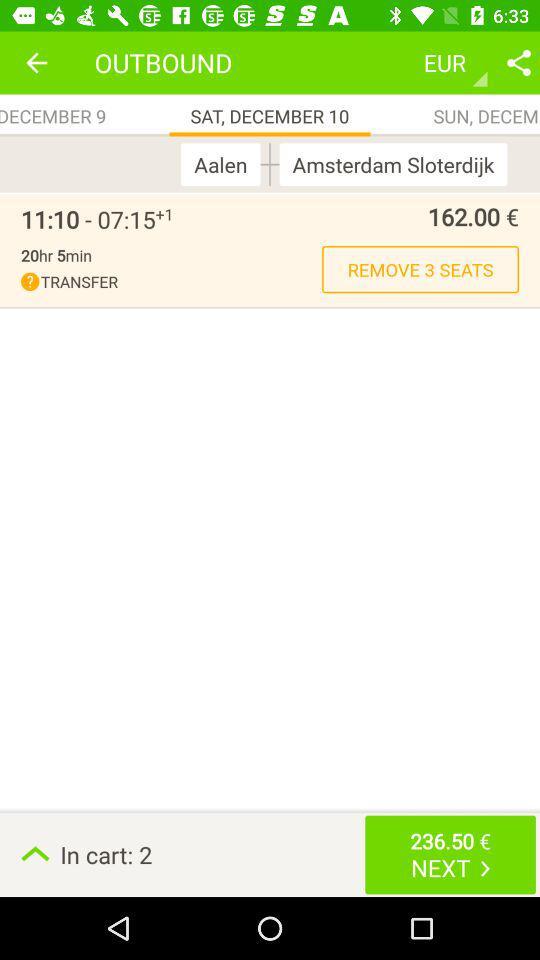How many euros is the ticket for? The ticket is for 162 euros. 